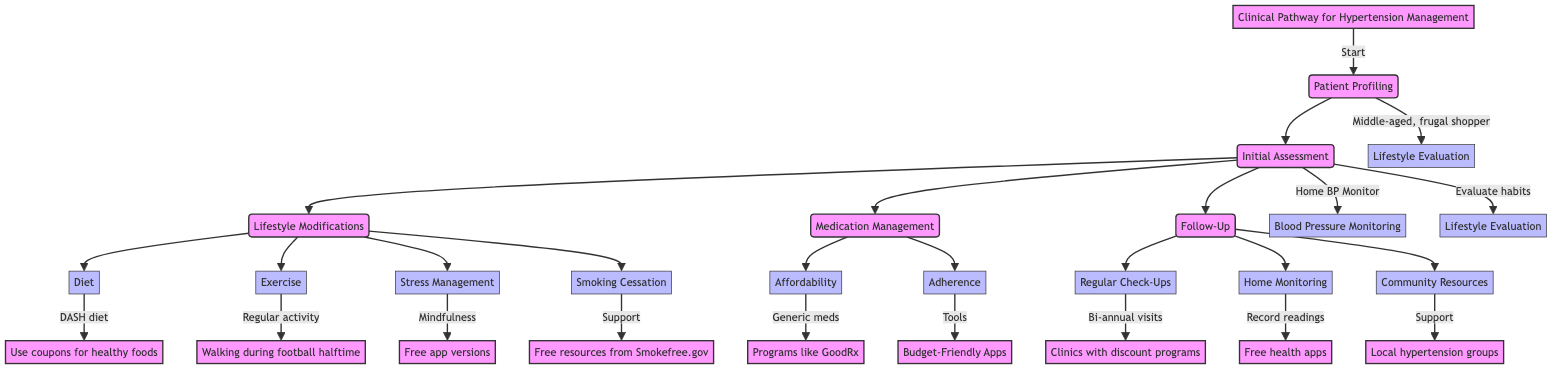What is the initial assessment for hypertension management? The diagram indicates that the initial assessment consists of blood pressure monitoring and lifestyle evaluation, specifically measuring blood pressure using a home monitor and evaluating the patient's habits.
Answer: Blood Pressure Monitoring, Lifestyle Evaluation How many lifestyle modifications are listed in the clinical pathway? In the diagram, there are four lifestyle modifications listed: diet, exercise, stress management, and smoking cessation.
Answer: Four What type of diet is recommended for managing hypertension? The diagram specifies the DASH (Dietary Approaches to Stop Hypertension) diet as the recommended diet for managing hypertension.
Answer: DASH diet What generic medication is suggested for affordability? The diagram lists Lisinopril as the recommended generic medication for managing hypertension affordably.
Answer: Lisinopril What community resources are available for follow-up support? The diagram mentions local hypertension support groups as a community resource available for patients during follow-up.
Answer: Local hypertension support groups Which exercise activity is highlighted for a frugal shopper during football games? The diagram suggests walking during football halftime as a budget-friendly exercise activity for the patient.
Answer: Walking during football halftime How often should patients schedule check-ups according to the pathway? The pathway indicates that patients should schedule bi-annual visits for regular check-ups with their primary care physician.
Answer: Bi-annual visits What tools can help improve medication adherence? The diagram states that setting reminders using budget-friendly apps and using pill organizers can help improve medication adherence.
Answer: Budget-Friendly Apps, Pill organizers What resources are available for smoking cessation support? The diagram lists free resources from Smokefree.gov as options available for support in smoking cessation.
Answer: Free resources from Smokefree.gov 